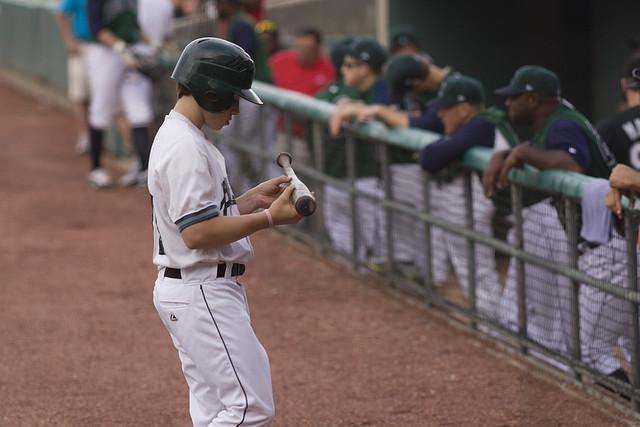What is the young man holding? Please explain your reasoning. baseball bat. A kid is on a baseball field in a baseball uniform holding a bat. 